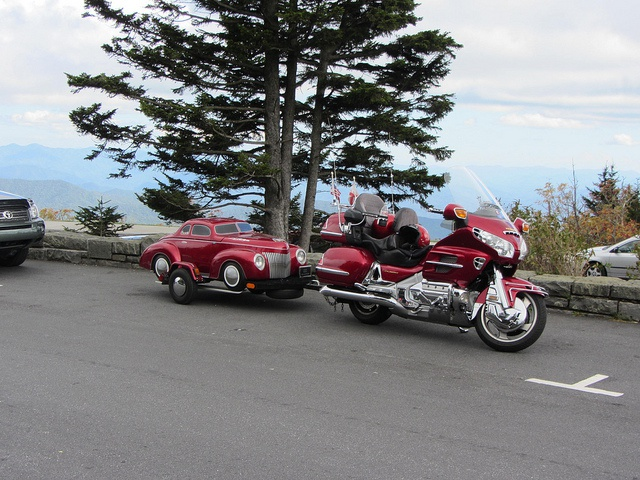Describe the objects in this image and their specific colors. I can see motorcycle in white, black, gray, lightgray, and darkgray tones, car in white, black, maroon, gray, and brown tones, car in white, black, purple, darkgray, and lightgray tones, and car in white, gray, darkgray, lightgray, and black tones in this image. 